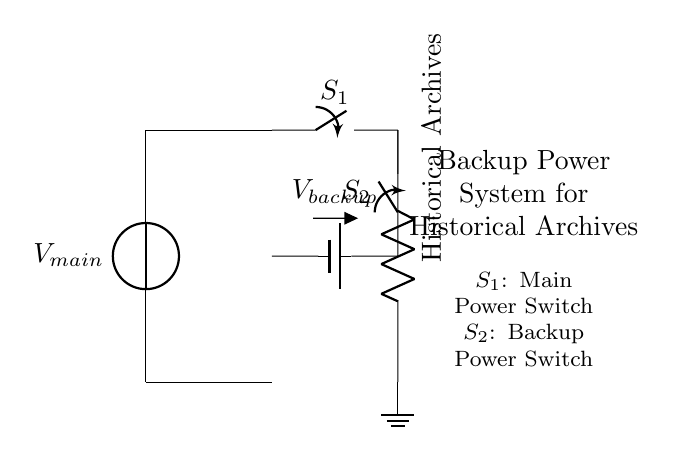What is the main power source in this circuit? The main power source is indicated by the voltage source labeled as V_main, which provides the primary electrical power for the circuit.
Answer: V_main What does S_1 represent in the circuit? S_1 is labeled as a switch (spst), which controls the connection to the main power supply, allowing it to be turned on or off.
Answer: Main Power Switch What component is used as a backup power source? The backup power source is represented by the battery labeled V_backup, which provides alternative power when the main supply is not available.
Answer: V_backup What is the load in this circuit? The load is specified as "Historical Archives," indicating that this is the component utilizing the electrical power in the backup system.
Answer: Historical Archives What is the function of switch S_2 in the circuit? Switch S_2 is used to connect or disconnect the backup power source to the load, allowing for manual control of power during a blackout or main power failure.
Answer: Backup Power Switch If V_main fails, which component provides power to the Archives? If V_main fails, the power to the Archives would be provided by the backup battery labeled V_backup, ensuring no interruption to the load.
Answer: V_backup How many power switches are there in this circuit? There are two power switches represented as S_1 and S_2, which control the main and backup power paths, respectively.
Answer: Two 